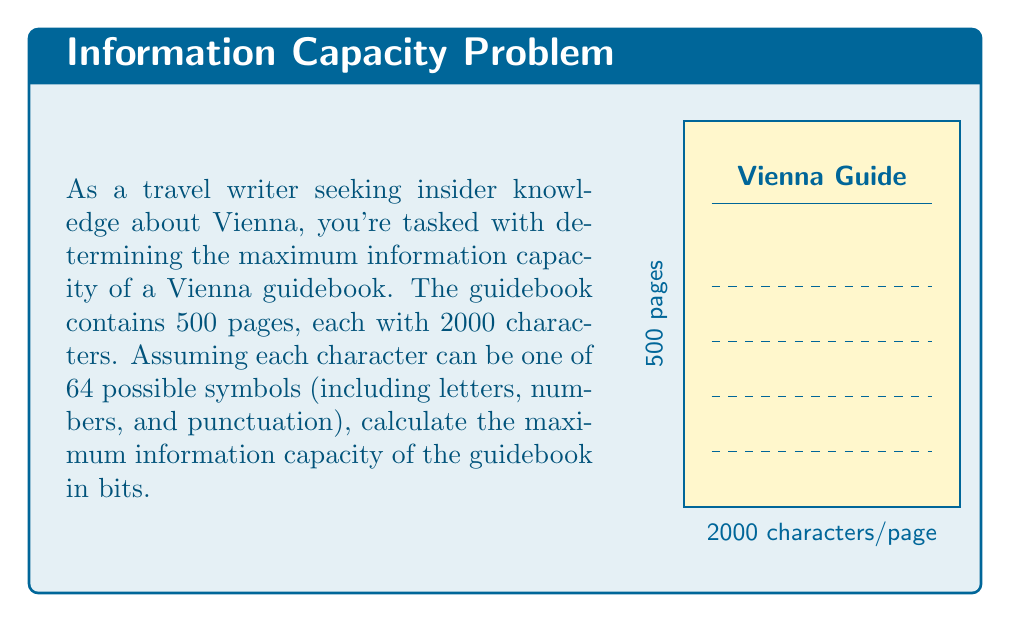What is the answer to this math problem? To solve this problem, we'll use concepts from information theory:

1) First, let's calculate the information content of a single character:
   - With 64 possible symbols, we have $\log_2(64) = 6$ bits of information per character.

2) Now, let's calculate the information content of a single page:
   - Each page has 2000 characters
   - Information per page = $2000 \times 6 = 12000$ bits

3) Finally, we'll calculate the total information capacity of the guidebook:
   - The guidebook has 500 pages
   - Total information capacity = $500 \times 12000 = 6,000,000$ bits

4) To express this in a more readable format, we can convert to megabits:
   $6,000,000 \text{ bits} = 6 \text{ megabits}$

Therefore, the maximum information capacity of the Vienna guidebook is 6 megabits.

Note: This calculation assumes maximum entropy, where each character is independent and equally likely. In practice, natural language has redundancies and patterns that reduce the actual information content.
Answer: 6 megabits 